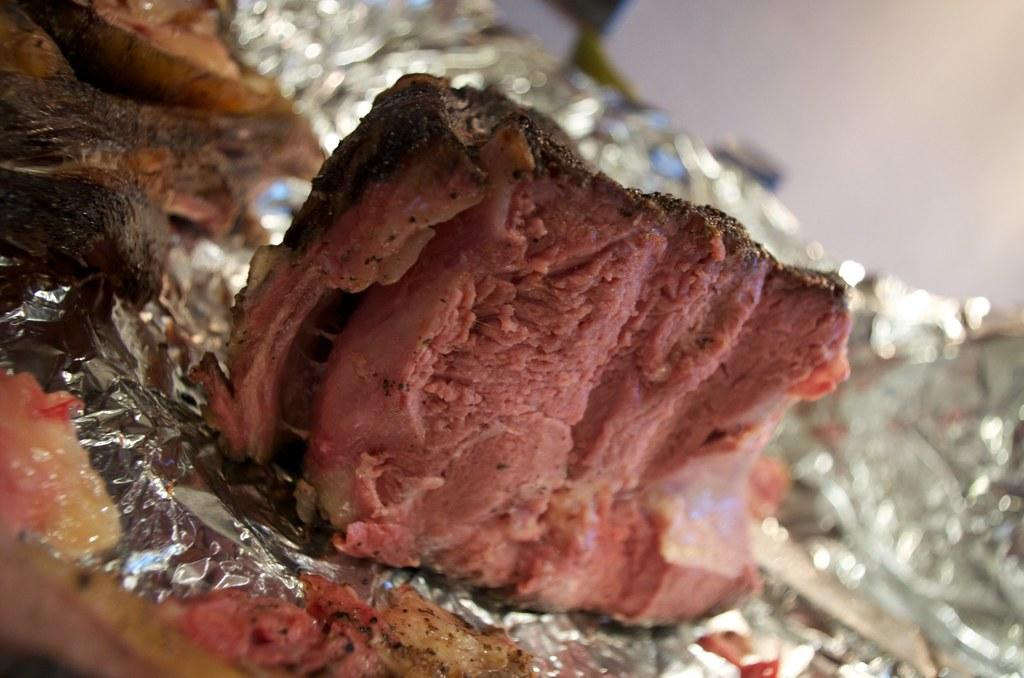What type of food is visible in the image? There is meat in the image. What is used to cover the meat in the image? There is an aluminium foil in the image. What can be seen in the background of the image? There is a wall in the background of the image. What type of harmony is being played by the coach in the image? There is no coach or any indication of music or harmony in the image; it features meat and aluminium foil. 